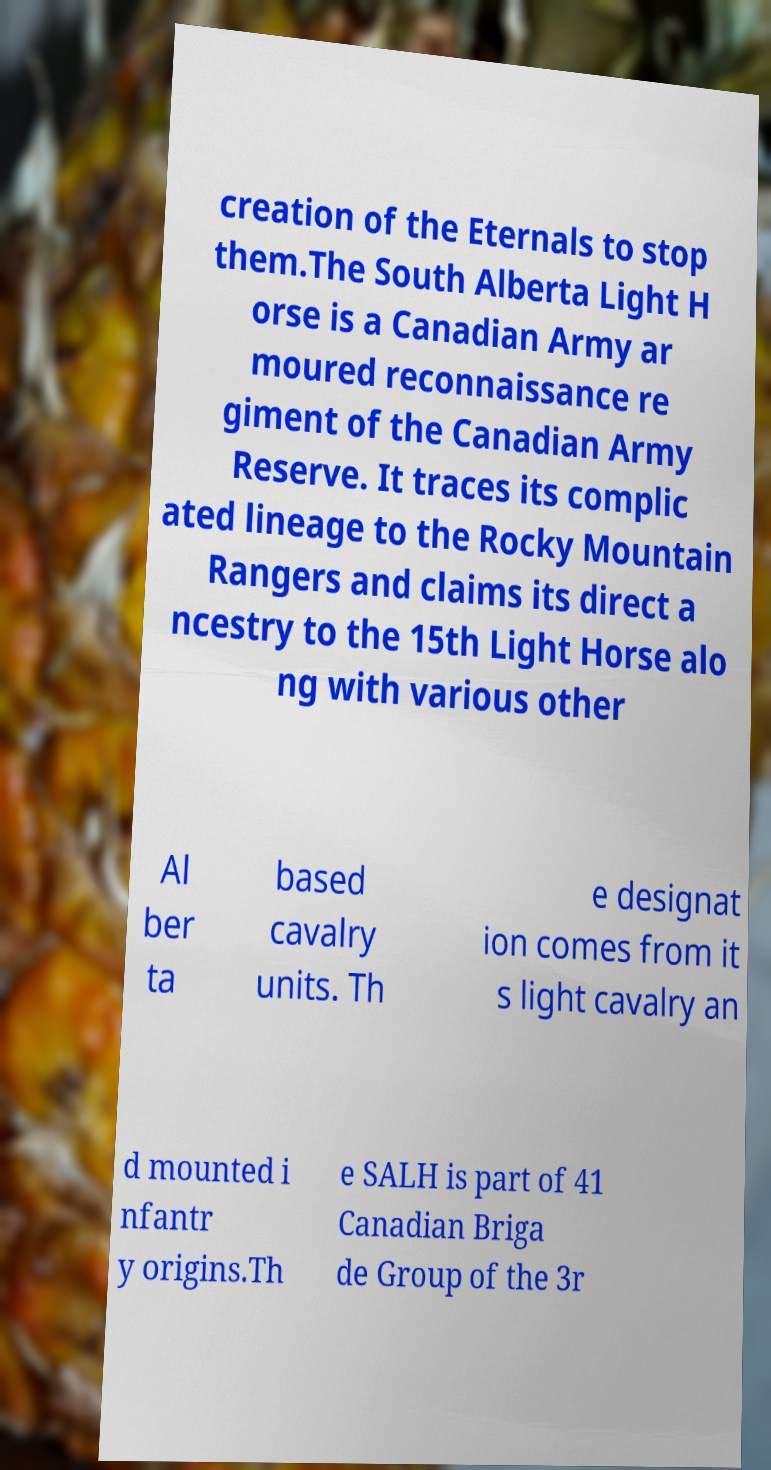I need the written content from this picture converted into text. Can you do that? creation of the Eternals to stop them.The South Alberta Light H orse is a Canadian Army ar moured reconnaissance re giment of the Canadian Army Reserve. It traces its complic ated lineage to the Rocky Mountain Rangers and claims its direct a ncestry to the 15th Light Horse alo ng with various other Al ber ta based cavalry units. Th e designat ion comes from it s light cavalry an d mounted i nfantr y origins.Th e SALH is part of 41 Canadian Briga de Group of the 3r 